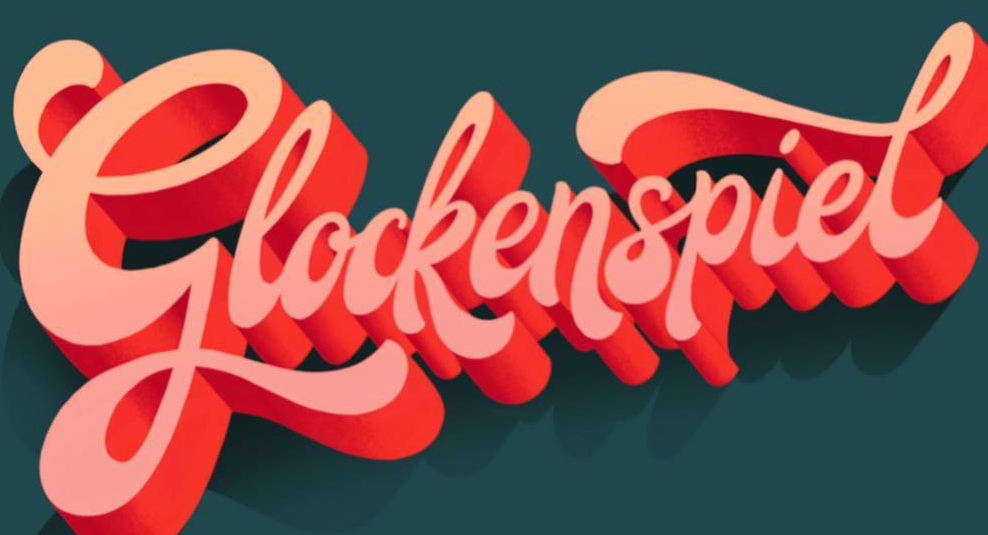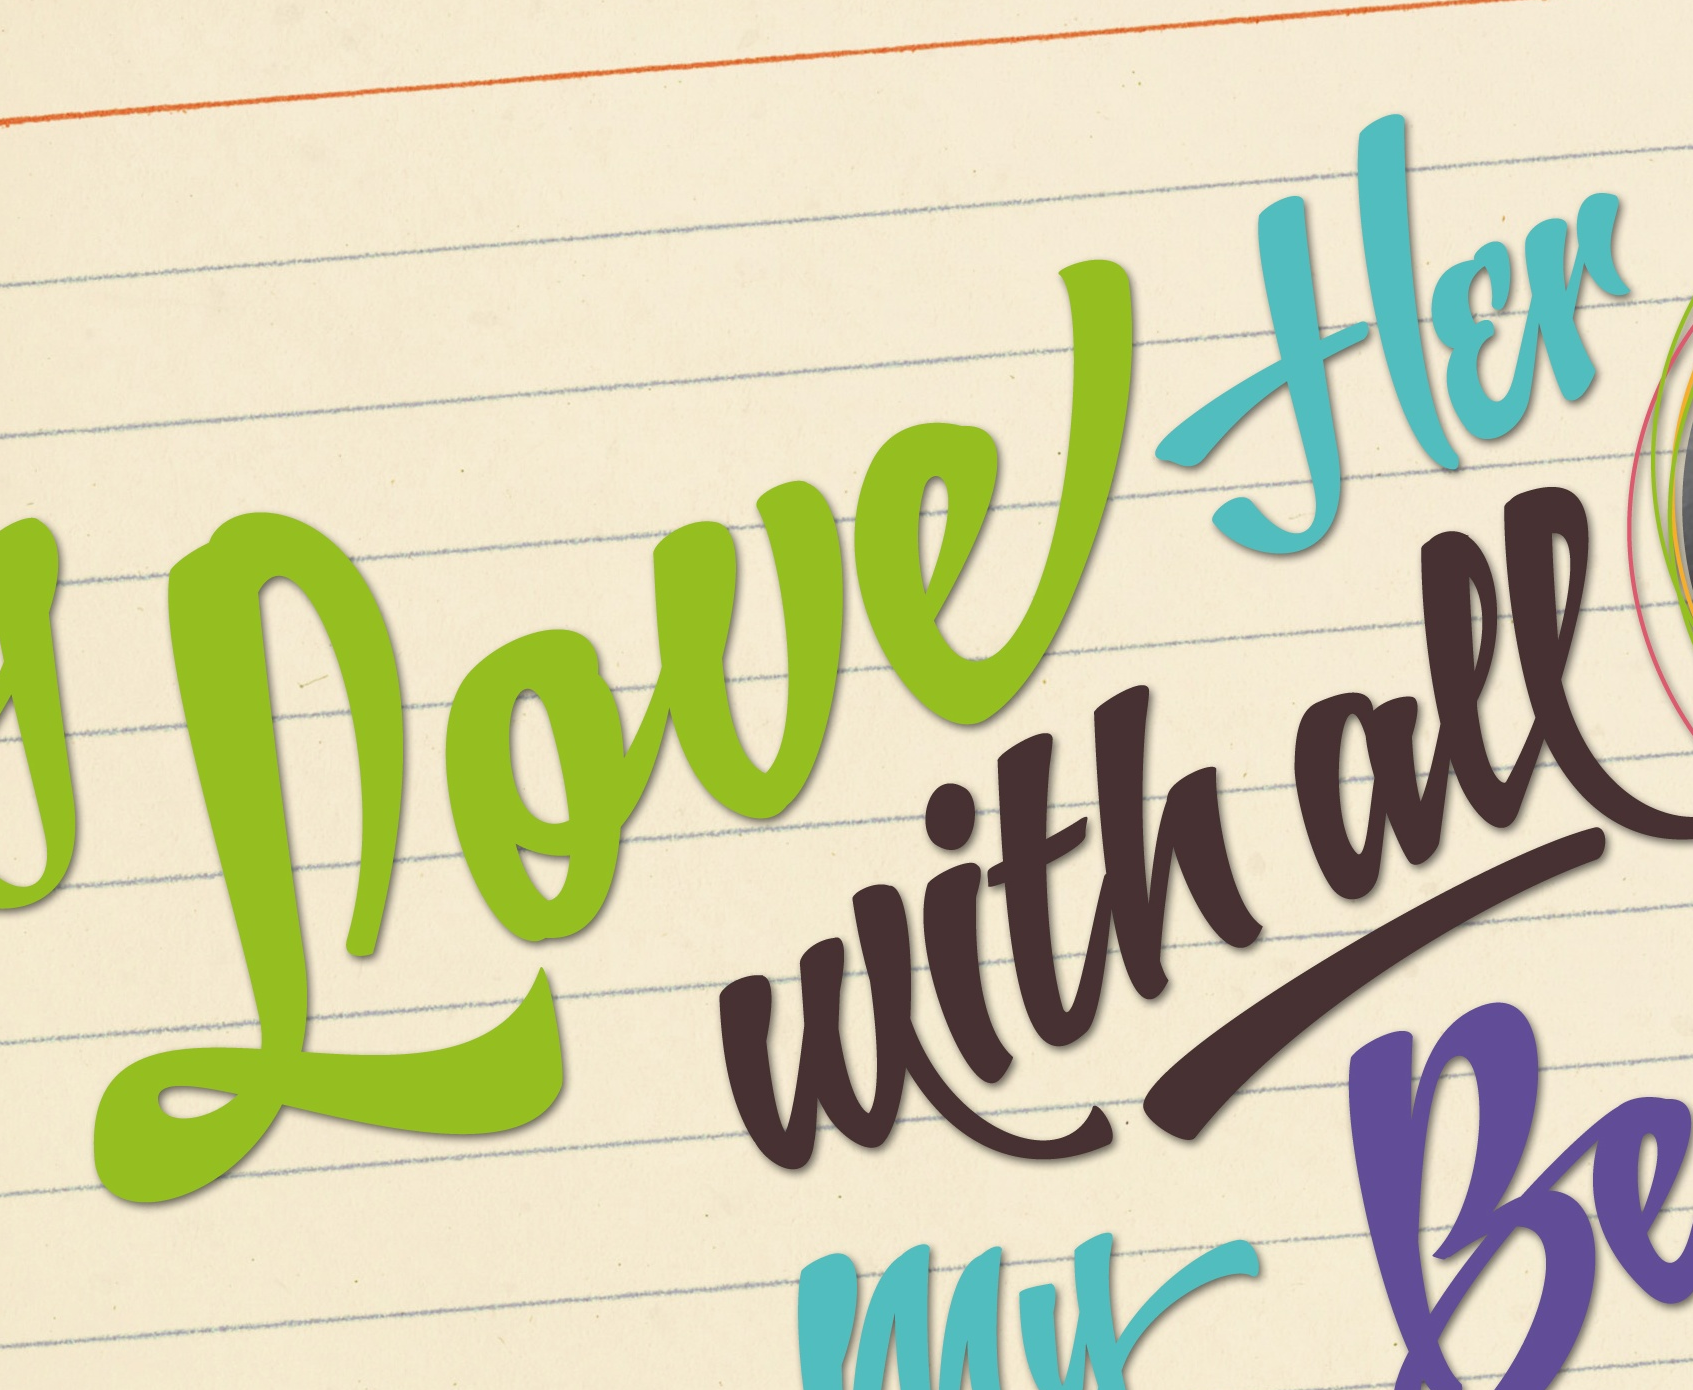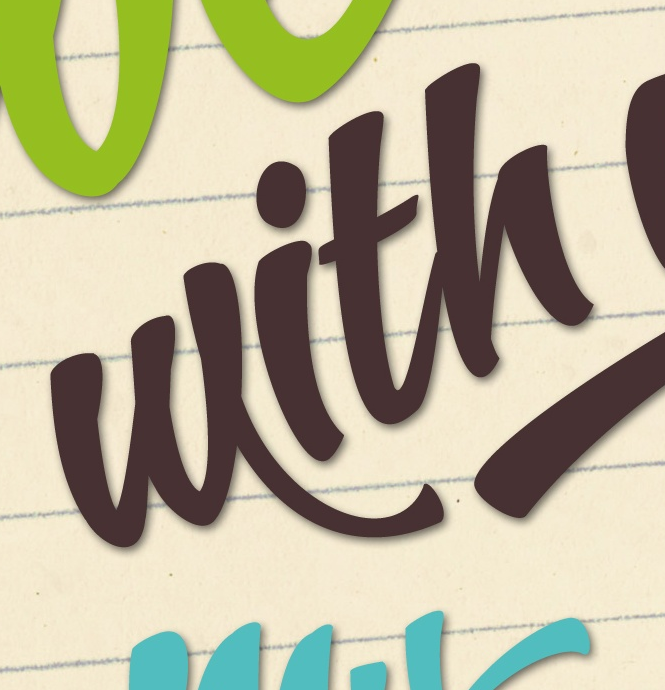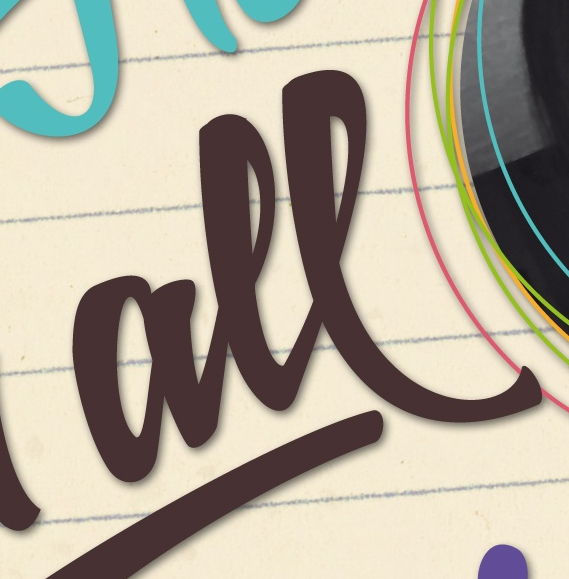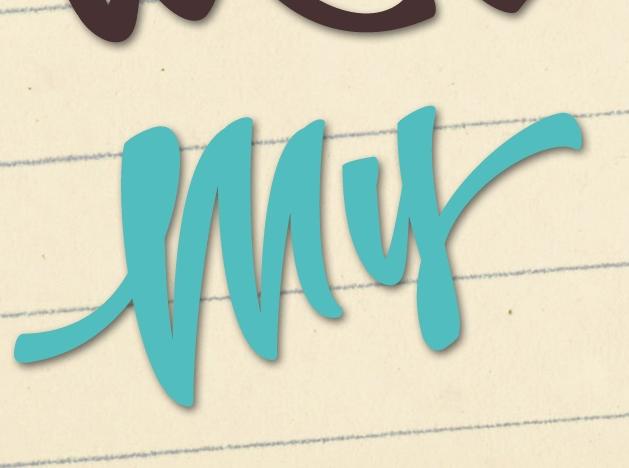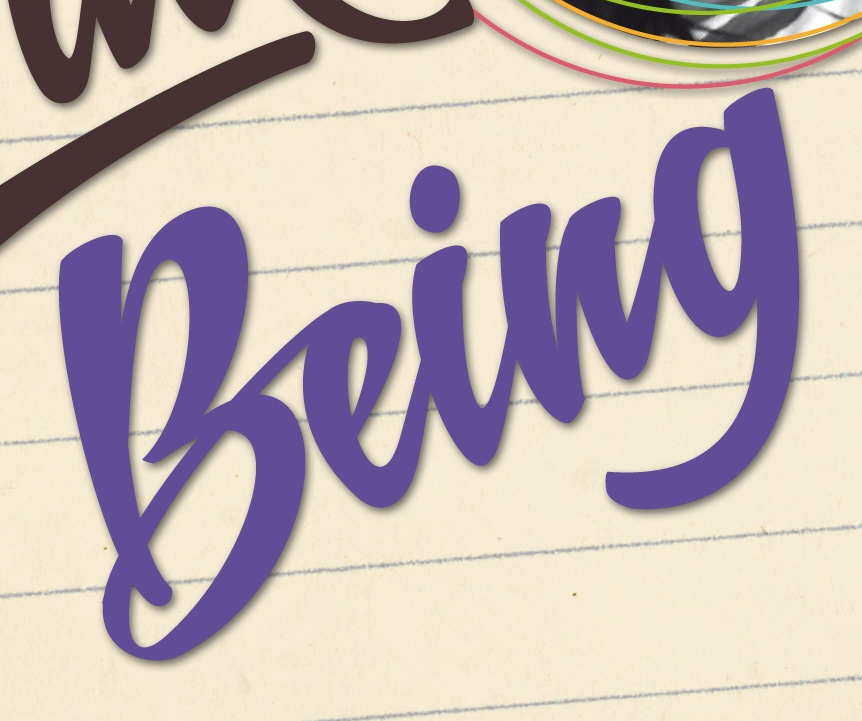Transcribe the words shown in these images in order, separated by a semicolon. Glockenspiel; Loueflɛr; with; all; my; being 